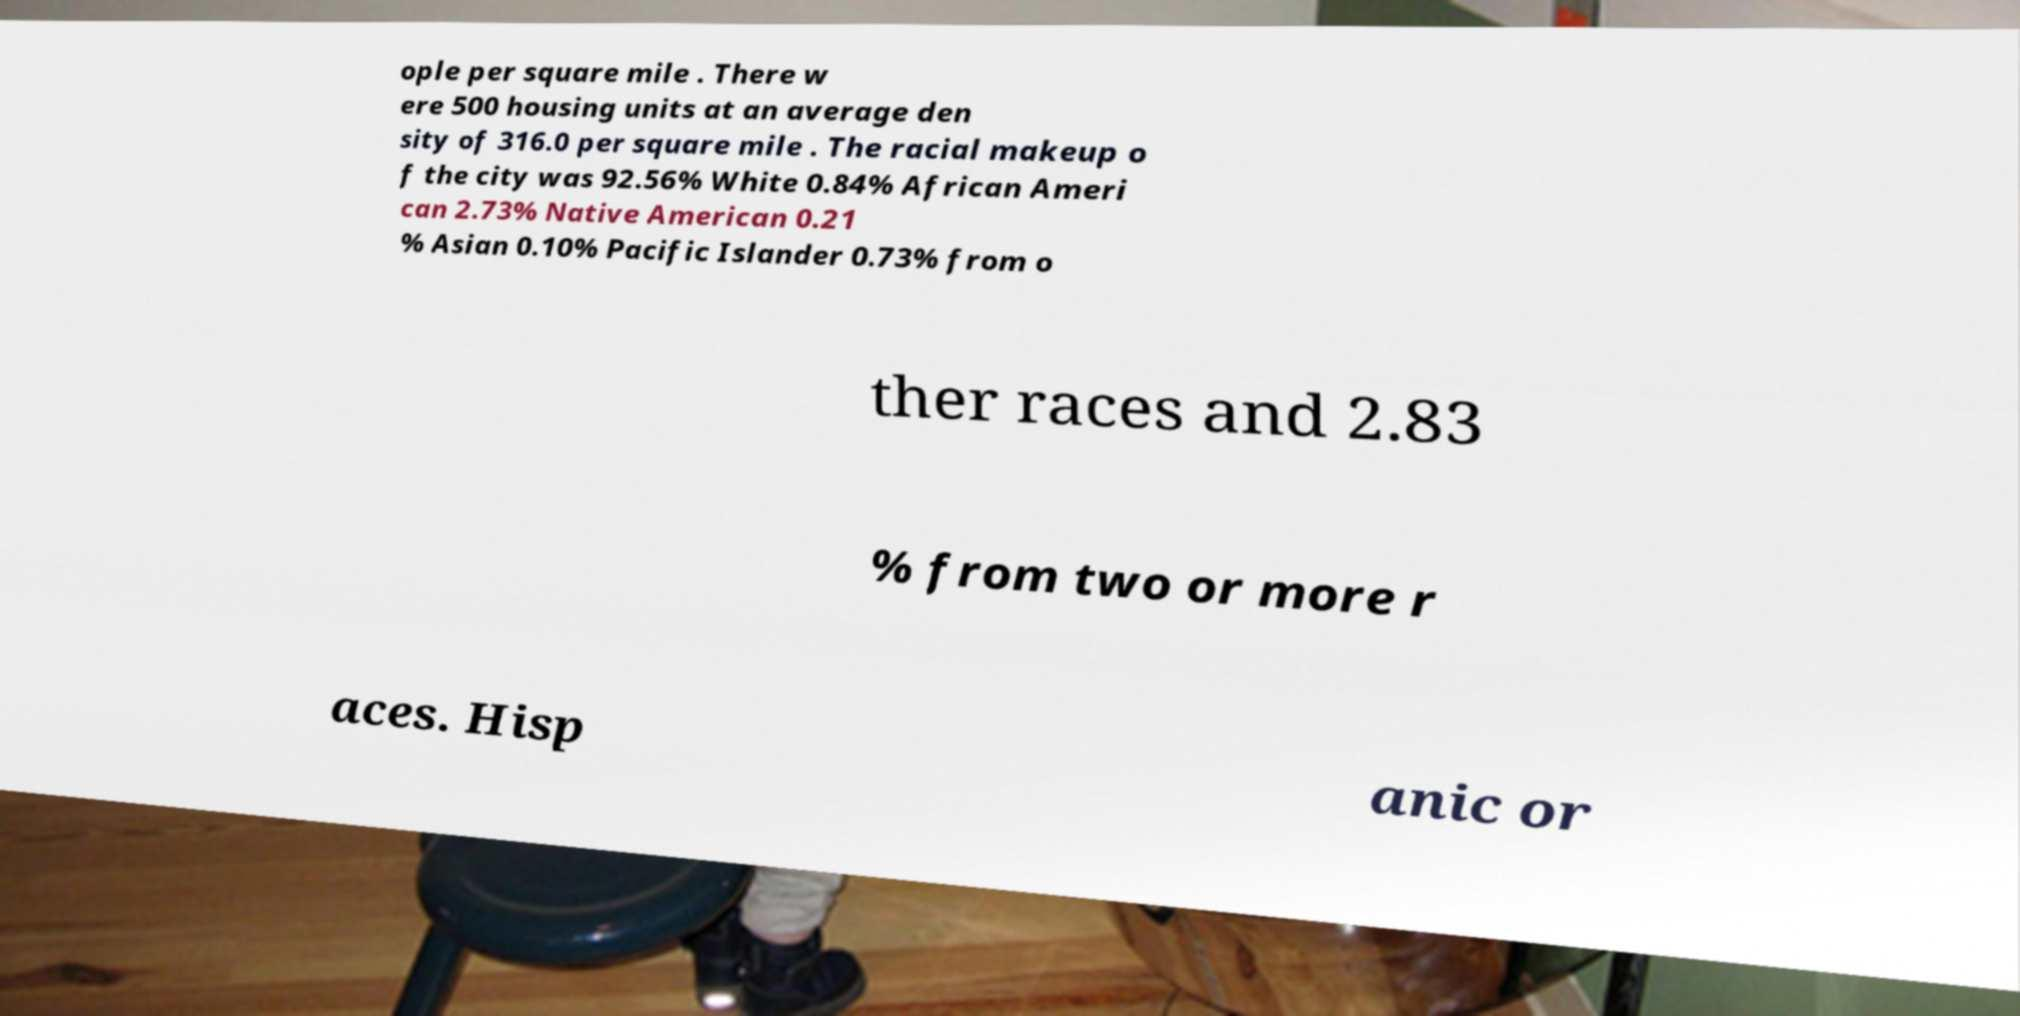Could you extract and type out the text from this image? ople per square mile . There w ere 500 housing units at an average den sity of 316.0 per square mile . The racial makeup o f the city was 92.56% White 0.84% African Ameri can 2.73% Native American 0.21 % Asian 0.10% Pacific Islander 0.73% from o ther races and 2.83 % from two or more r aces. Hisp anic or 